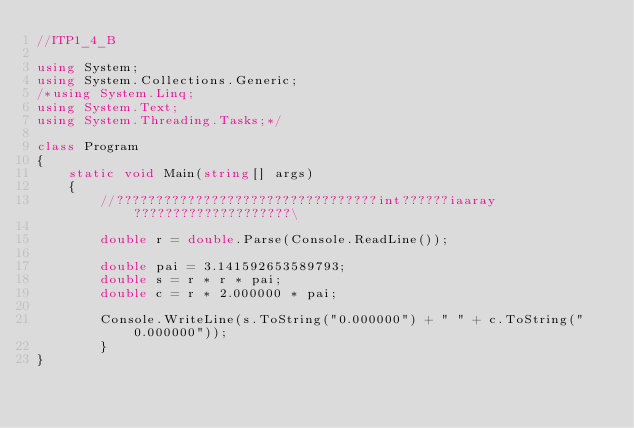Convert code to text. <code><loc_0><loc_0><loc_500><loc_500><_C#_>//ITP1_4_B

using System;
using System.Collections.Generic;
/*using System.Linq;
using System.Text;
using System.Threading.Tasks;*/

class Program
{
    static void Main(string[] args)
    {
        //?????????????????????????????????int??????iaaray????????????????????\

        double r = double.Parse(Console.ReadLine());

        double pai = 3.141592653589793;
        double s = r * r * pai;
        double c = r * 2.000000 * pai;

        Console.WriteLine(s.ToString("0.000000") + " " + c.ToString("0.000000"));
        }
}</code> 